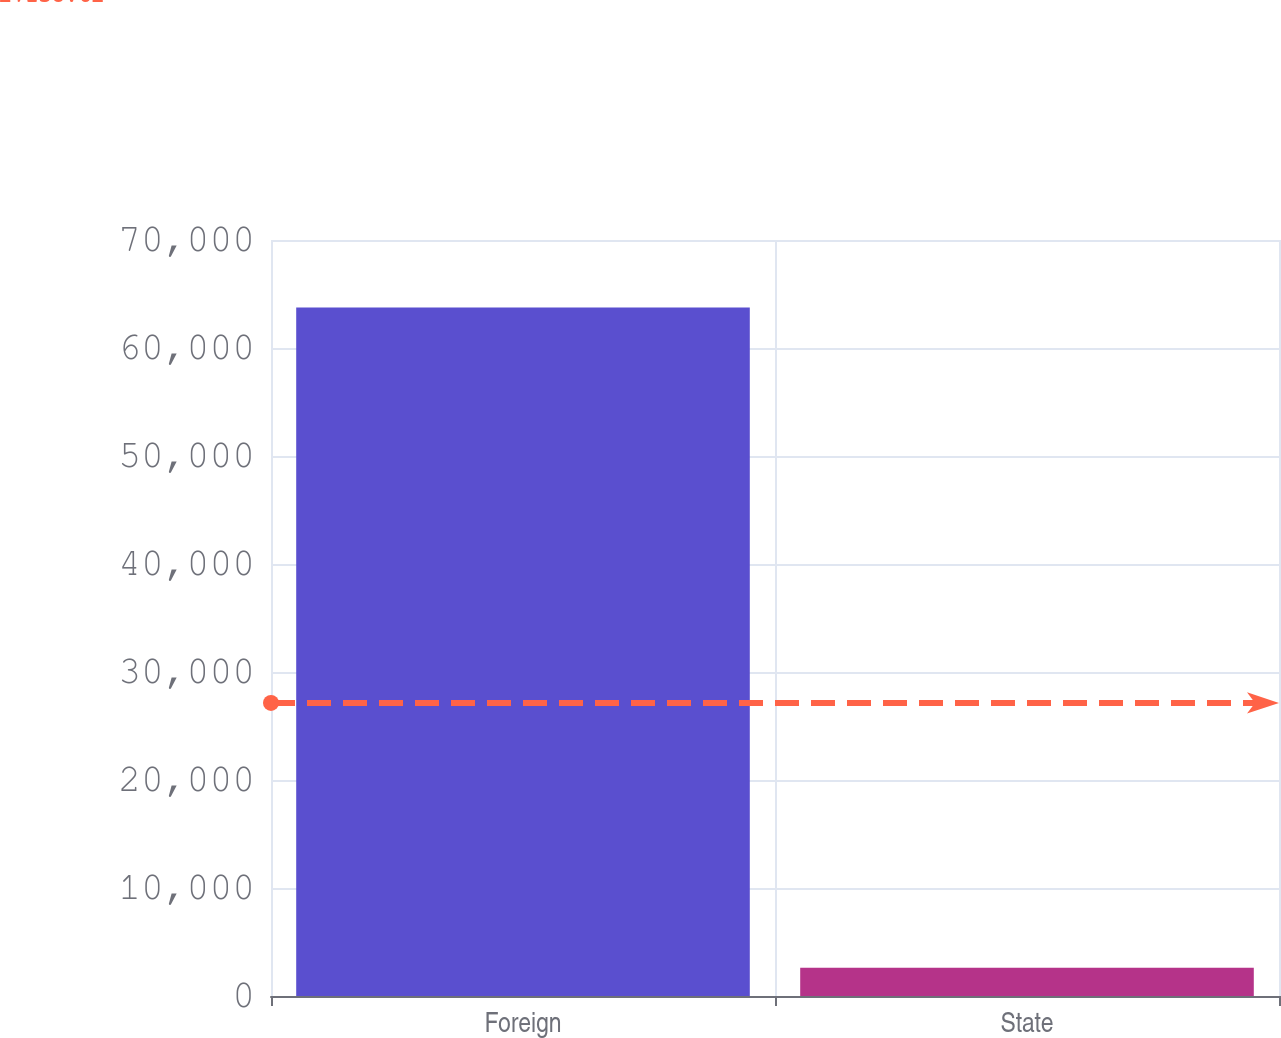Convert chart. <chart><loc_0><loc_0><loc_500><loc_500><bar_chart><fcel>Foreign<fcel>State<nl><fcel>63753<fcel>2627<nl></chart> 